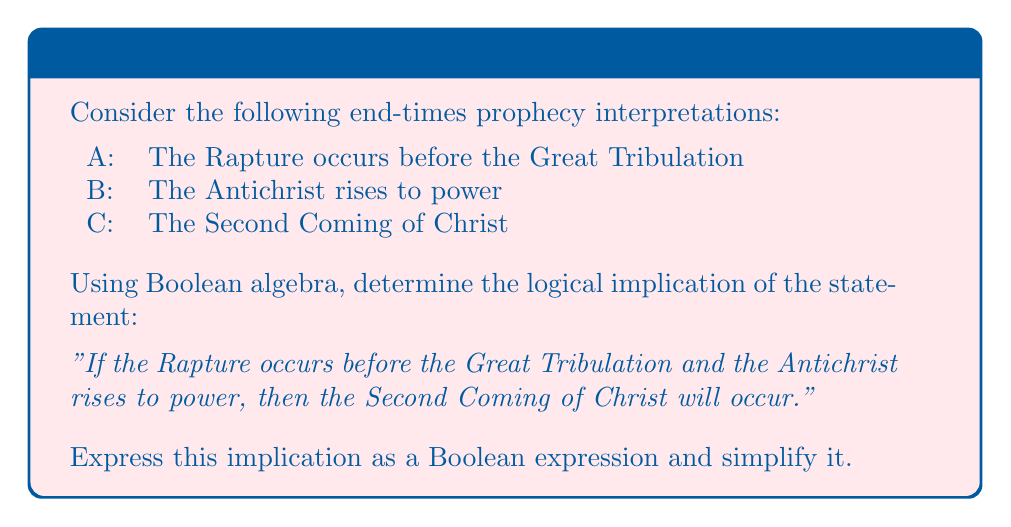What is the answer to this math problem? Let's approach this step-by-step:

1) First, we need to translate the given statement into a logical implication using Boolean algebra. The statement can be written as:

   $$(A \land B) \Rightarrow C$$

2) In Boolean algebra, an implication $P \Rightarrow Q$ is equivalent to $\lnot P \lor Q$. Therefore, we can rewrite our expression as:

   $$\lnot(A \land B) \lor C$$

3) Using De Morgan's law, we can distribute the negation:

   $$(\lnot A \lor \lnot B) \lor C$$

4) Now, we can use the associative property of OR to rearrange the terms:

   $$\lnot A \lor \lnot B \lor C$$

5) This expression can be interpreted as: "Either the Rapture does not occur before the Great Tribulation, or the Antichrist does not rise to power, or the Second Coming of Christ occurs."

6) This is the simplest form of the Boolean expression representing the given logical implication.
Answer: $\lnot A \lor \lnot B \lor C$ 